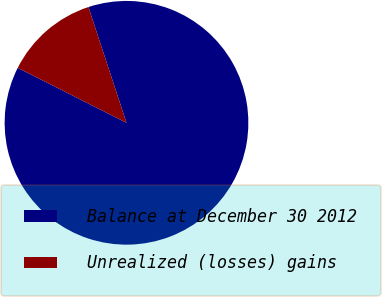Convert chart. <chart><loc_0><loc_0><loc_500><loc_500><pie_chart><fcel>Balance at December 30 2012<fcel>Unrealized (losses) gains<nl><fcel>87.5%<fcel>12.5%<nl></chart> 